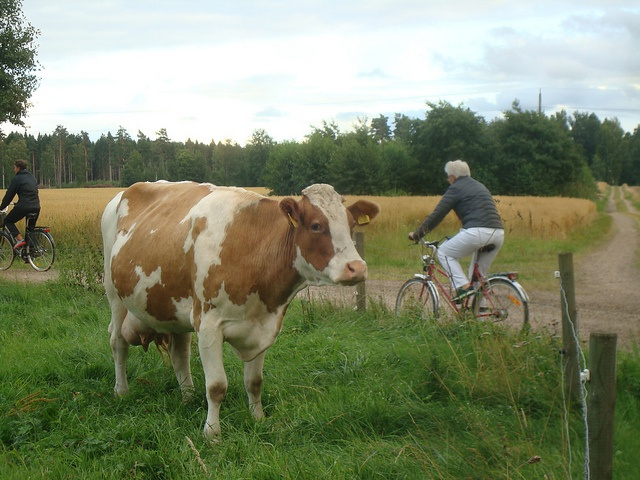Describe the objects in this image and their specific colors. I can see cow in darkgreen, olive, tan, darkgray, and gray tones, bicycle in darkgreen and gray tones, people in darkgreen, gray, darkgray, black, and purple tones, people in darkgreen, black, tan, and gray tones, and bicycle in darkgreen, black, gray, and maroon tones in this image. 